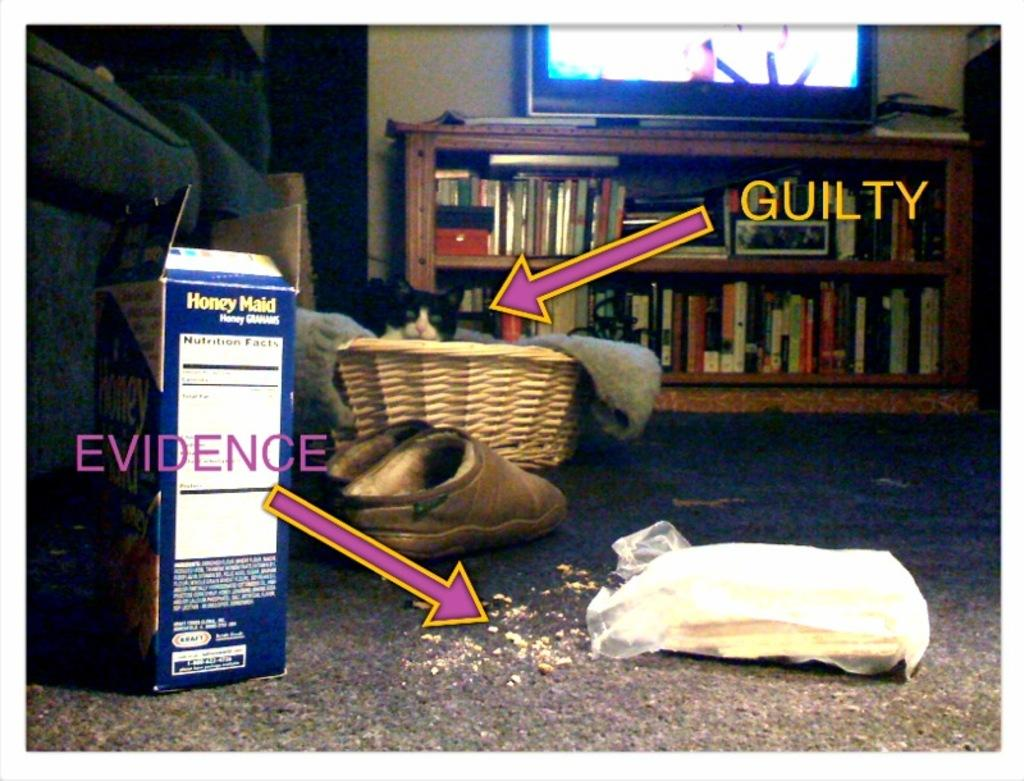<image>
Give a short and clear explanation of the subsequent image. the word guilty next to a basket with stuff in it 